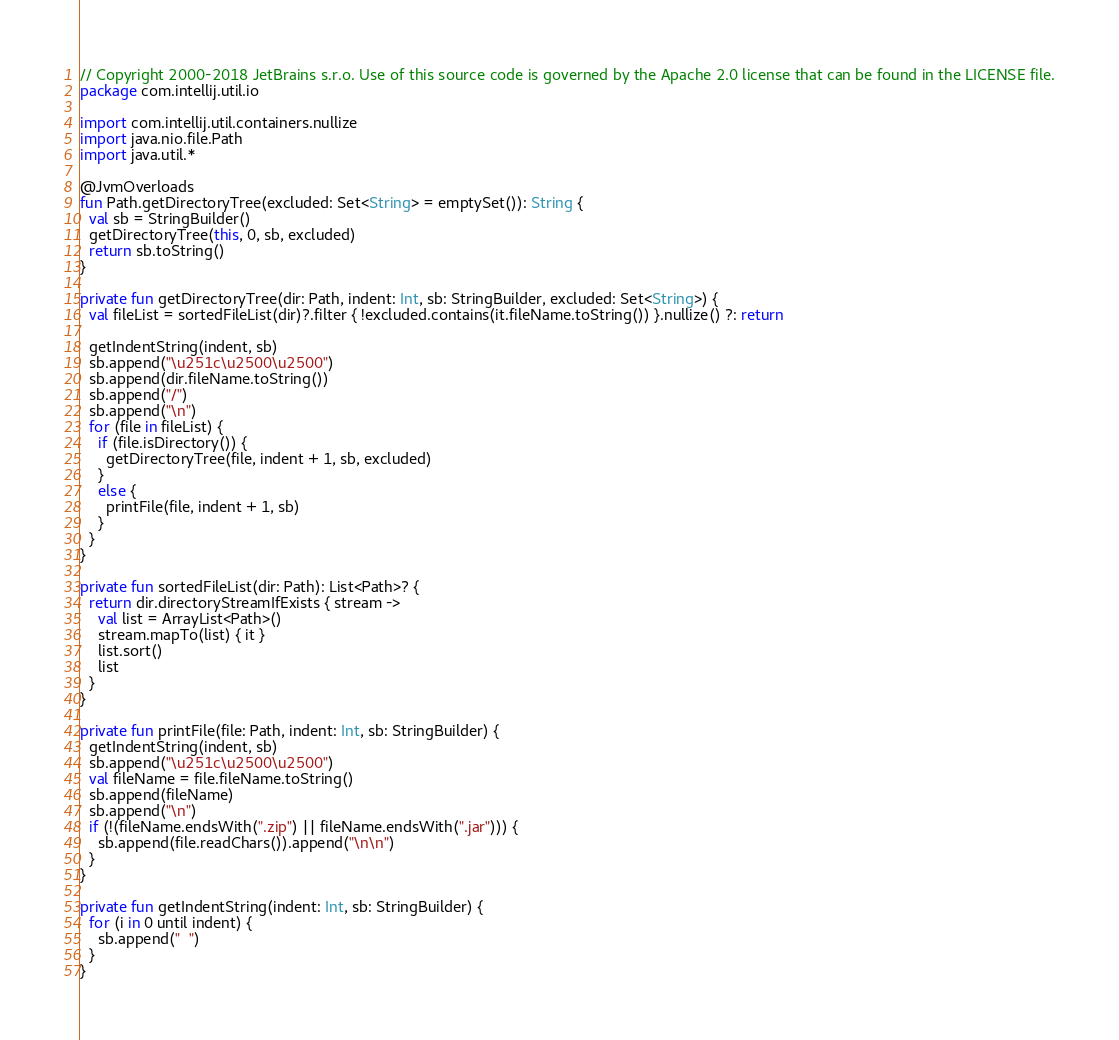Convert code to text. <code><loc_0><loc_0><loc_500><loc_500><_Kotlin_>// Copyright 2000-2018 JetBrains s.r.o. Use of this source code is governed by the Apache 2.0 license that can be found in the LICENSE file.
package com.intellij.util.io

import com.intellij.util.containers.nullize
import java.nio.file.Path
import java.util.*

@JvmOverloads
fun Path.getDirectoryTree(excluded: Set<String> = emptySet()): String {
  val sb = StringBuilder()
  getDirectoryTree(this, 0, sb, excluded)
  return sb.toString()
}

private fun getDirectoryTree(dir: Path, indent: Int, sb: StringBuilder, excluded: Set<String>) {
  val fileList = sortedFileList(dir)?.filter { !excluded.contains(it.fileName.toString()) }.nullize() ?: return

  getIndentString(indent, sb)
  sb.append("\u251c\u2500\u2500")
  sb.append(dir.fileName.toString())
  sb.append("/")
  sb.append("\n")
  for (file in fileList) {
    if (file.isDirectory()) {
      getDirectoryTree(file, indent + 1, sb, excluded)
    }
    else {
      printFile(file, indent + 1, sb)
    }
  }
}

private fun sortedFileList(dir: Path): List<Path>? {
  return dir.directoryStreamIfExists { stream ->
    val list = ArrayList<Path>()
    stream.mapTo(list) { it }
    list.sort()
    list
  }
}

private fun printFile(file: Path, indent: Int, sb: StringBuilder) {
  getIndentString(indent, sb)
  sb.append("\u251c\u2500\u2500")
  val fileName = file.fileName.toString()
  sb.append(fileName)
  sb.append("\n")
  if (!(fileName.endsWith(".zip") || fileName.endsWith(".jar"))) {
    sb.append(file.readChars()).append("\n\n")
  }
}

private fun getIndentString(indent: Int, sb: StringBuilder) {
  for (i in 0 until indent) {
    sb.append("  ")
  }
}</code> 